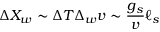<formula> <loc_0><loc_0><loc_500><loc_500>\Delta X _ { w } \sim \Delta T \Delta _ { w } v \sim { \frac { g _ { s } } { v } } \ell _ { s }</formula> 